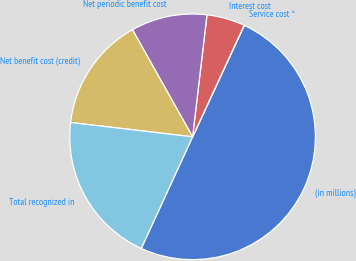Convert chart to OTSL. <chart><loc_0><loc_0><loc_500><loc_500><pie_chart><fcel>(in millions)<fcel>Service cost ^<fcel>Interest cost<fcel>Net periodic benefit cost<fcel>Net benefit cost (credit)<fcel>Total recognized in<nl><fcel>49.95%<fcel>0.02%<fcel>5.02%<fcel>10.01%<fcel>15.0%<fcel>20.0%<nl></chart> 